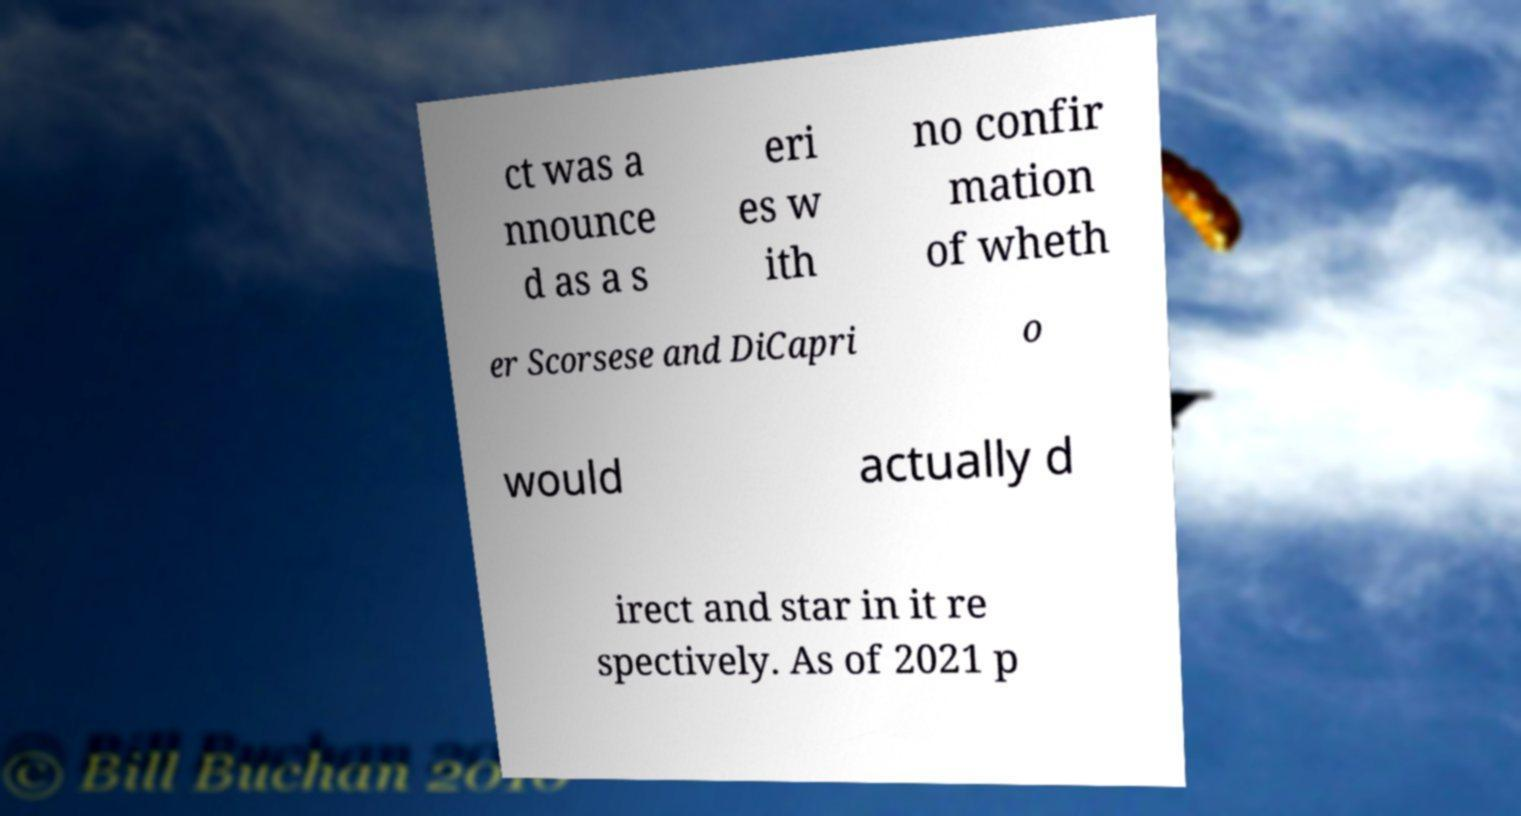Can you read and provide the text displayed in the image?This photo seems to have some interesting text. Can you extract and type it out for me? ct was a nnounce d as a s eri es w ith no confir mation of wheth er Scorsese and DiCapri o would actually d irect and star in it re spectively. As of 2021 p 